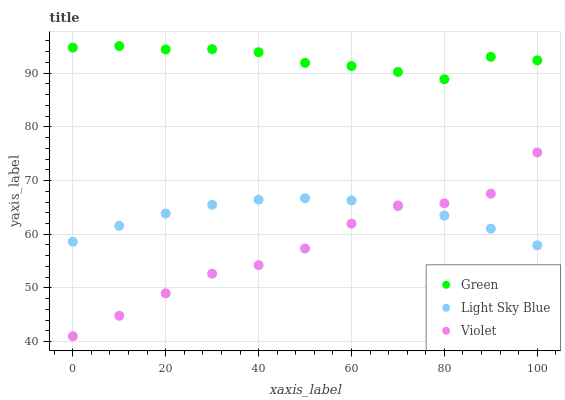Does Violet have the minimum area under the curve?
Answer yes or no. Yes. Does Green have the maximum area under the curve?
Answer yes or no. Yes. Does Green have the minimum area under the curve?
Answer yes or no. No. Does Violet have the maximum area under the curve?
Answer yes or no. No. Is Light Sky Blue the smoothest?
Answer yes or no. Yes. Is Violet the roughest?
Answer yes or no. Yes. Is Green the smoothest?
Answer yes or no. No. Is Green the roughest?
Answer yes or no. No. Does Violet have the lowest value?
Answer yes or no. Yes. Does Green have the lowest value?
Answer yes or no. No. Does Green have the highest value?
Answer yes or no. Yes. Does Violet have the highest value?
Answer yes or no. No. Is Light Sky Blue less than Green?
Answer yes or no. Yes. Is Green greater than Light Sky Blue?
Answer yes or no. Yes. Does Violet intersect Light Sky Blue?
Answer yes or no. Yes. Is Violet less than Light Sky Blue?
Answer yes or no. No. Is Violet greater than Light Sky Blue?
Answer yes or no. No. Does Light Sky Blue intersect Green?
Answer yes or no. No. 